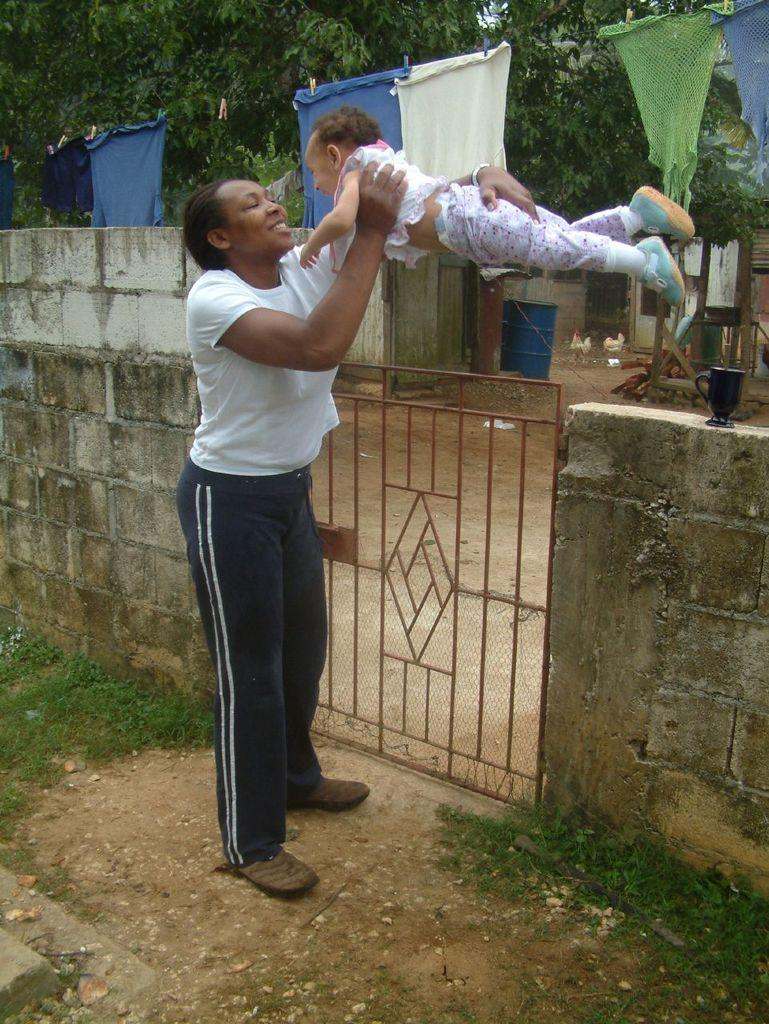Who is in the image? There is a woman in the image. What is the woman holding? The woman is holding a baby. What can be seen in the background of the image? There is a mesh, shredded leaves on the ground, grass, a building, trees, and clothes hanged on a rope in the image. What objects are visible in the image? Drums and hens are visible in the image. What is the woman's location in the image? The woman is standing on grass in the image. Where is the pig located in the image? There is no pig present in the image. What type of roof is covering the building in the image? The provided facts do not mention the type of roof covering the building in the image. 